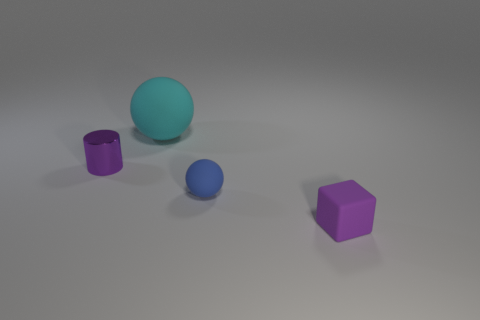Is there anything else that has the same size as the cyan matte ball?
Your answer should be compact. No. There is a cube; does it have the same color as the tiny thing that is behind the small blue ball?
Your answer should be very brief. Yes. What color is the other object that is the same shape as the big cyan object?
Your answer should be very brief. Blue. There is a small thing that is behind the block and on the right side of the cyan sphere; what shape is it?
Offer a terse response. Sphere. How many cyan things are either big matte spheres or matte spheres?
Your answer should be compact. 1. Do the matte object in front of the tiny matte sphere and the cyan matte ball left of the small blue thing have the same size?
Give a very brief answer. No. How many things are either small brown cylinders or matte spheres?
Offer a very short reply. 2. Are there any other small matte things that have the same shape as the purple matte object?
Give a very brief answer. No. Are there fewer cyan spheres than green metal spheres?
Keep it short and to the point. No. Is the large cyan thing the same shape as the tiny blue thing?
Give a very brief answer. Yes. 